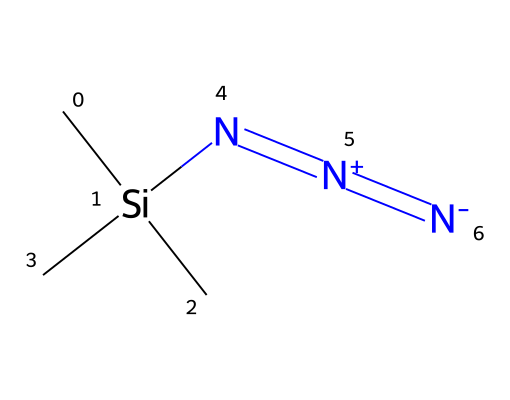what is the name of the compound represented? The compound represented is called trimethylsilyl azide. This is derived from the components of the SMILES, where the presence of the trimethylsilyl group (C[Si](C)(C)) and the azide moiety (N=[N+]=[N-]) indicates the compound's name.
Answer: trimethylsilyl azide how many nitrogen atoms are in the structure? The SMILES structure indicates three nitrogen atoms in total, as noted by the three N’s in the azide functional group (N=[N+]=[N-]). Each ‘N’ represents one nitrogen atom in the molecule.
Answer: three what type of functional group does this compound contain? The compound contains an azide functional group, evident from the presence of the nitrogen triple bond indicated by the SMILES. The pattern N=[N+]=[N-] shows that this is a characteristic azide group.
Answer: azide what is the effect of the trimethylsilyl group on solubility? The trimethylsilyl group enhances solubility in organic solvents due to its hydrophobic, organic nature, which contrasts with the polar azide group. This synergistic effect can lead to an increased overall solubility in various environments.
Answer: enhances solubility how does this compound relate to anti-corrosion coatings? Trimethylsilyl azide is used in the synthesis of triazoles, which are known for their anti-corrosion properties. The structural attributes of triazoles provide stability and protective qualities to materials, especially in computer hardware applications.
Answer: synthesis of triazoles what makes the azide group reactive? The azide group (N=[N+]=[N-]) is highly reactive due to the presence of the negatively charged nitrogen, creating a strain and making it susceptible to nucleophilic attack. This feature contributes to its utility in various chemical reactions.
Answer: high reactivity how many carbon atoms are present in the structure? There are three carbon atoms in the structural formula due to the presence of the three 'C’s in the trimethylsilyl part of the SMILES notation (C[Si](C)(C)).
Answer: three 